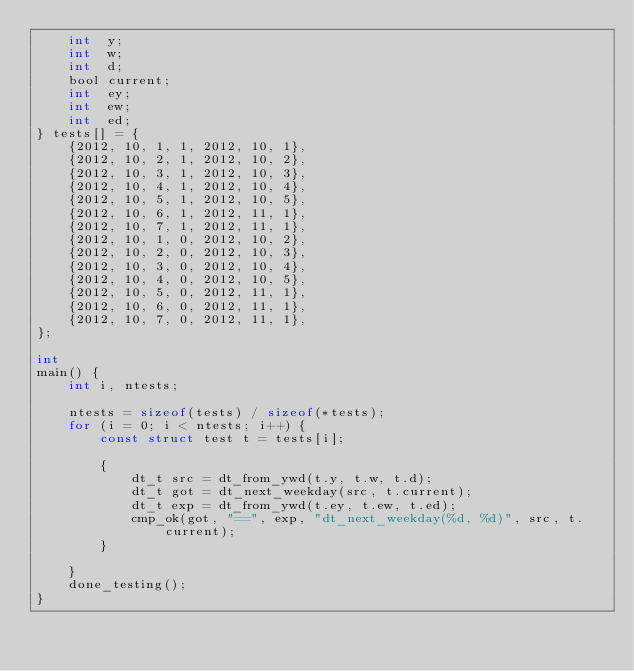<code> <loc_0><loc_0><loc_500><loc_500><_C_>    int  y;
    int  w;
    int  d;
    bool current;
    int  ey;
    int  ew;
    int  ed;
} tests[] = {
    {2012, 10, 1, 1, 2012, 10, 1},
    {2012, 10, 2, 1, 2012, 10, 2},
    {2012, 10, 3, 1, 2012, 10, 3},
    {2012, 10, 4, 1, 2012, 10, 4},
    {2012, 10, 5, 1, 2012, 10, 5},
    {2012, 10, 6, 1, 2012, 11, 1},
    {2012, 10, 7, 1, 2012, 11, 1},
    {2012, 10, 1, 0, 2012, 10, 2},
    {2012, 10, 2, 0, 2012, 10, 3},
    {2012, 10, 3, 0, 2012, 10, 4},
    {2012, 10, 4, 0, 2012, 10, 5},
    {2012, 10, 5, 0, 2012, 11, 1},
    {2012, 10, 6, 0, 2012, 11, 1},
    {2012, 10, 7, 0, 2012, 11, 1},
};

int 
main() {
    int i, ntests;

    ntests = sizeof(tests) / sizeof(*tests);
    for (i = 0; i < ntests; i++) {
        const struct test t = tests[i];

        {
            dt_t src = dt_from_ywd(t.y, t.w, t.d);
            dt_t got = dt_next_weekday(src, t.current);
            dt_t exp = dt_from_ywd(t.ey, t.ew, t.ed);
            cmp_ok(got, "==", exp, "dt_next_weekday(%d, %d)", src, t.current);
        }

    }
    done_testing();
}
</code> 